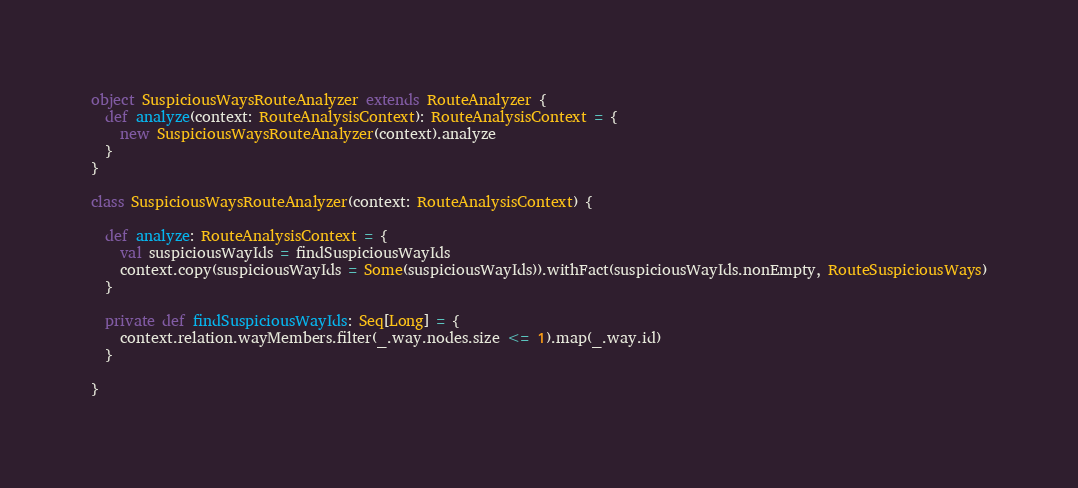Convert code to text. <code><loc_0><loc_0><loc_500><loc_500><_Scala_>
object SuspiciousWaysRouteAnalyzer extends RouteAnalyzer {
  def analyze(context: RouteAnalysisContext): RouteAnalysisContext = {
    new SuspiciousWaysRouteAnalyzer(context).analyze
  }
}

class SuspiciousWaysRouteAnalyzer(context: RouteAnalysisContext) {

  def analyze: RouteAnalysisContext = {
    val suspiciousWayIds = findSuspiciousWayIds
    context.copy(suspiciousWayIds = Some(suspiciousWayIds)).withFact(suspiciousWayIds.nonEmpty, RouteSuspiciousWays)
  }

  private def findSuspiciousWayIds: Seq[Long] = {
    context.relation.wayMembers.filter(_.way.nodes.size <= 1).map(_.way.id)
  }

}
</code> 